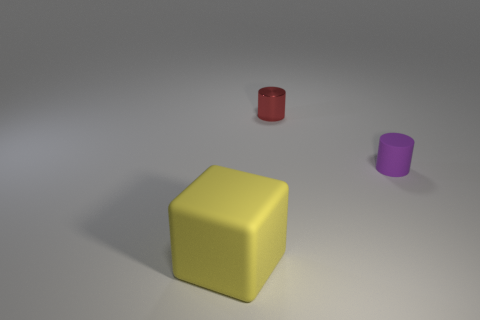Add 3 tiny things. How many objects exist? 6 Subtract all cubes. How many objects are left? 2 Add 3 small metal cylinders. How many small metal cylinders are left? 4 Add 2 small things. How many small things exist? 4 Subtract 0 purple blocks. How many objects are left? 3 Subtract all tiny purple metal cylinders. Subtract all big yellow matte things. How many objects are left? 2 